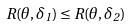Convert formula to latex. <formula><loc_0><loc_0><loc_500><loc_500>R ( \theta , \delta _ { 1 } ) \leq R ( \theta , \delta _ { 2 } )</formula> 